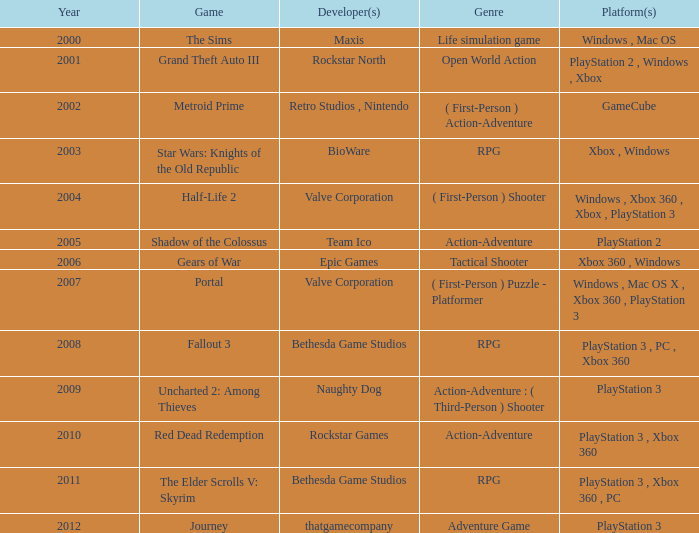What was the game that came out in 2005? Shadow of the Colossus. 